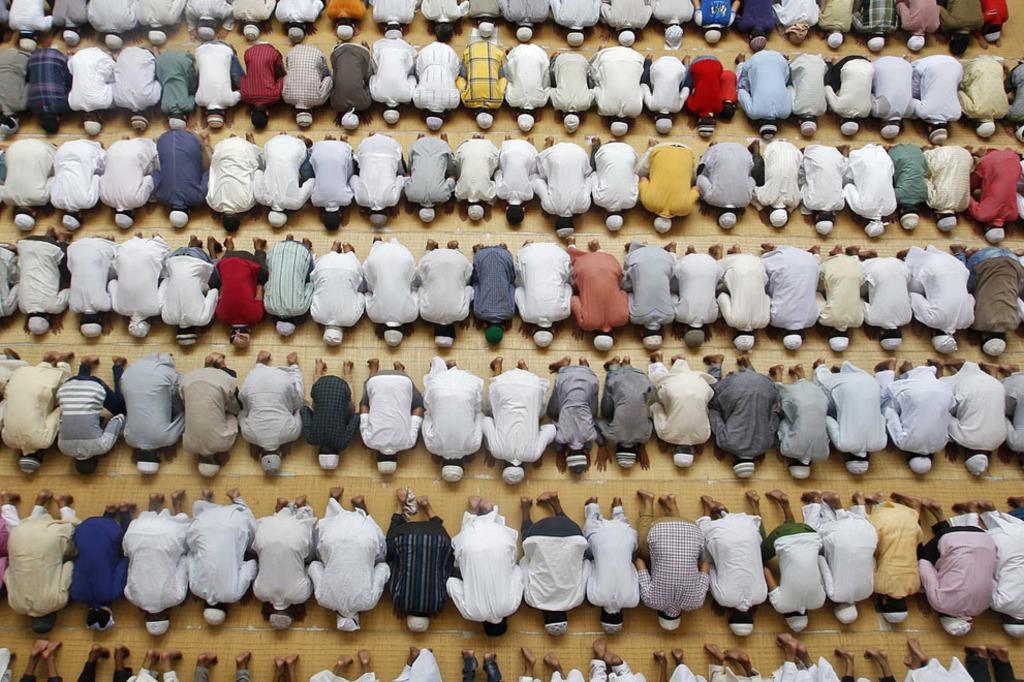Please provide a concise description of this image. In this picture we can see a group of people on the ground. 